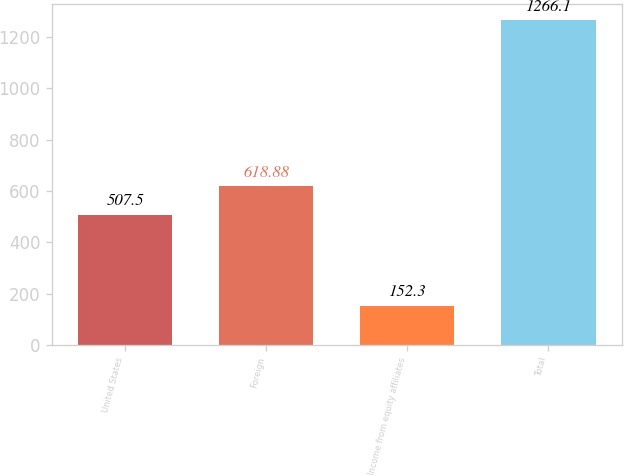<chart> <loc_0><loc_0><loc_500><loc_500><bar_chart><fcel>United States<fcel>Foreign<fcel>Income from equity affiliates<fcel>Total<nl><fcel>507.5<fcel>618.88<fcel>152.3<fcel>1266.1<nl></chart> 